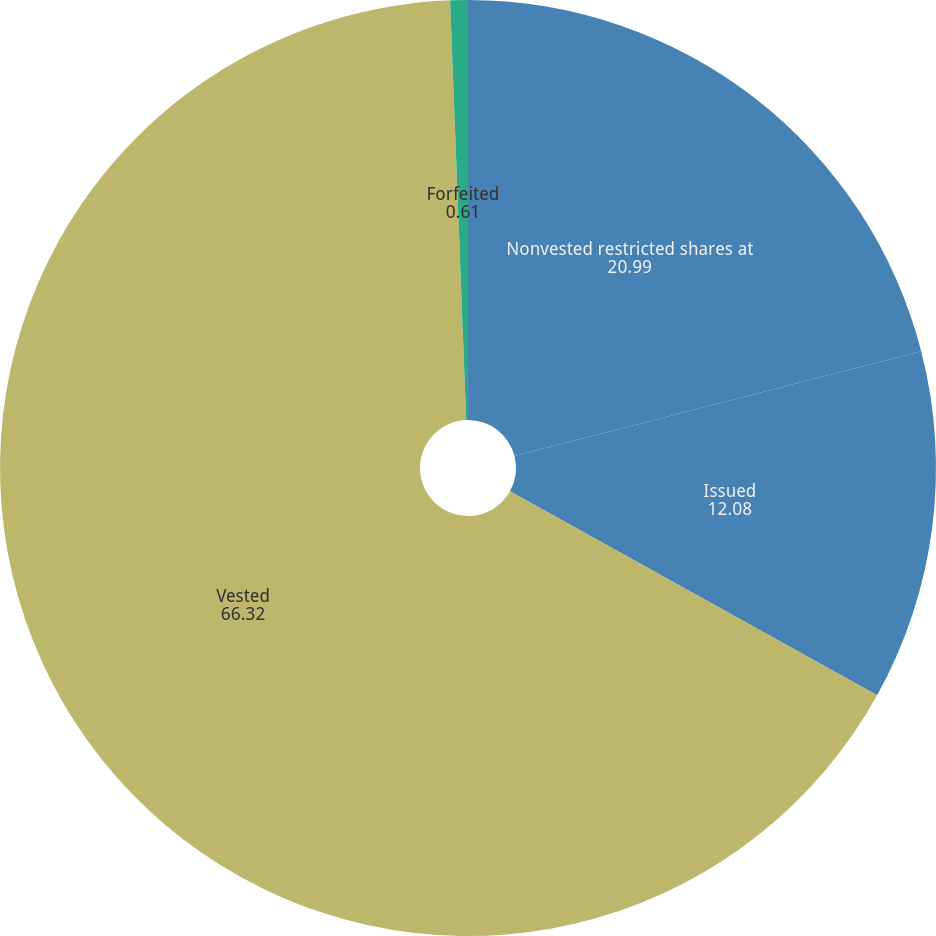<chart> <loc_0><loc_0><loc_500><loc_500><pie_chart><fcel>Nonvested restricted shares at<fcel>Issued<fcel>Vested<fcel>Forfeited<nl><fcel>20.99%<fcel>12.08%<fcel>66.32%<fcel>0.61%<nl></chart> 